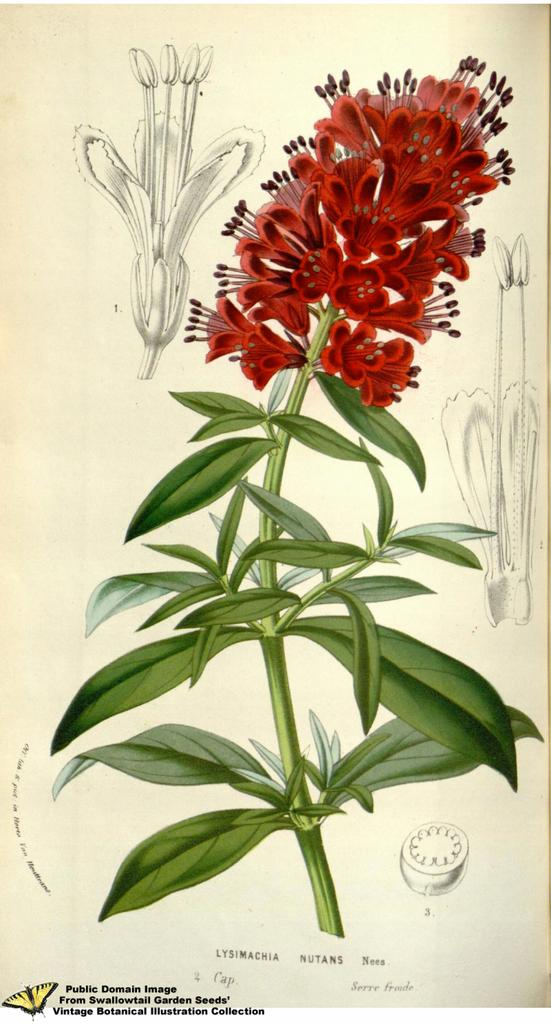What is the main subject of the painting in the image? The painting depicts a flower. What is the painting placed on in the image? The painting is on a sheet. What type of parent is shown in the painting? There is no parent depicted in the painting; it features a flower. What appliance is used to clean the painting in the image? There is no appliance present in the image, as it only shows a painting of a flower on a sheet. 